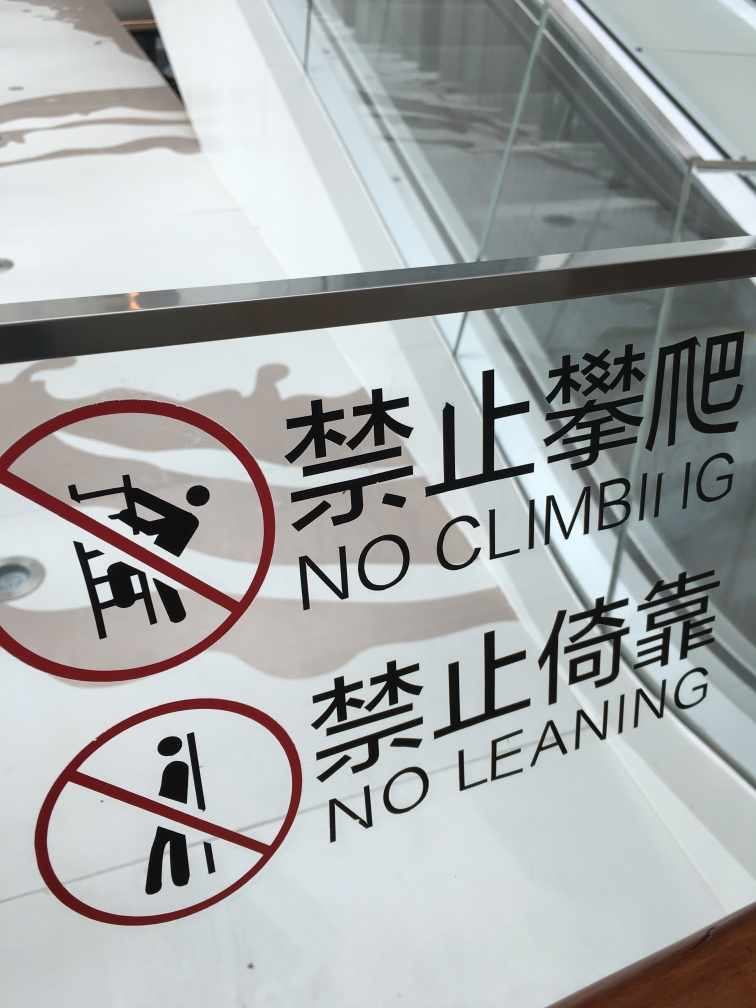Are the colors relatively monotone? Yes, the colors in the image are relatively monotone, with the predominant use of stark white and bold red, particularly evident in the safety signs that display text and symbols to indicate 'No Climbing' and 'No Leaning.' 